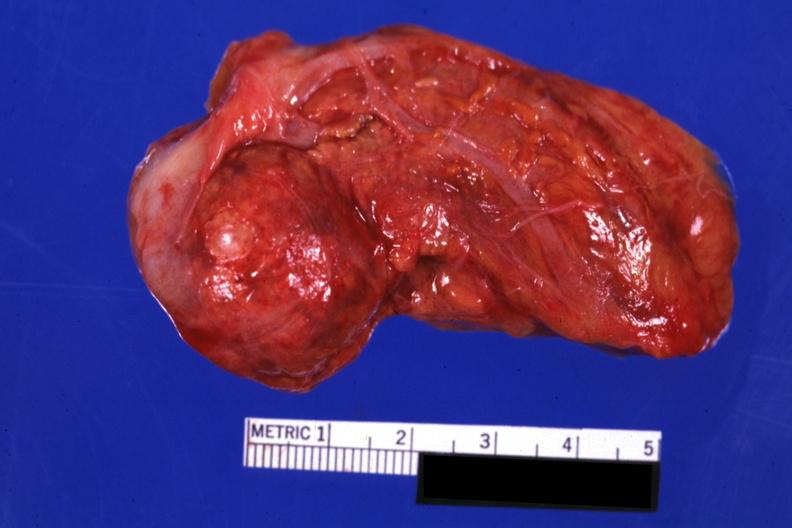does this image show intact gland with obvious nodule?
Answer the question using a single word or phrase. Yes 